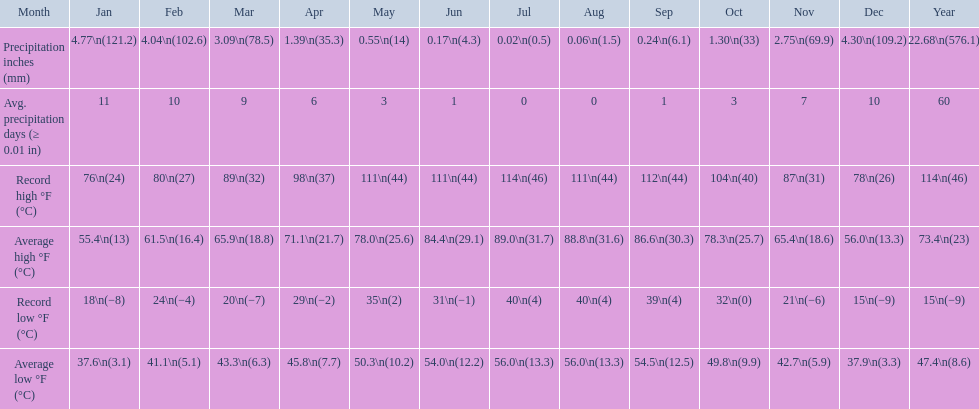Which month had an average high of 89.0 degrees and an average low of 56.0 degrees? July. 